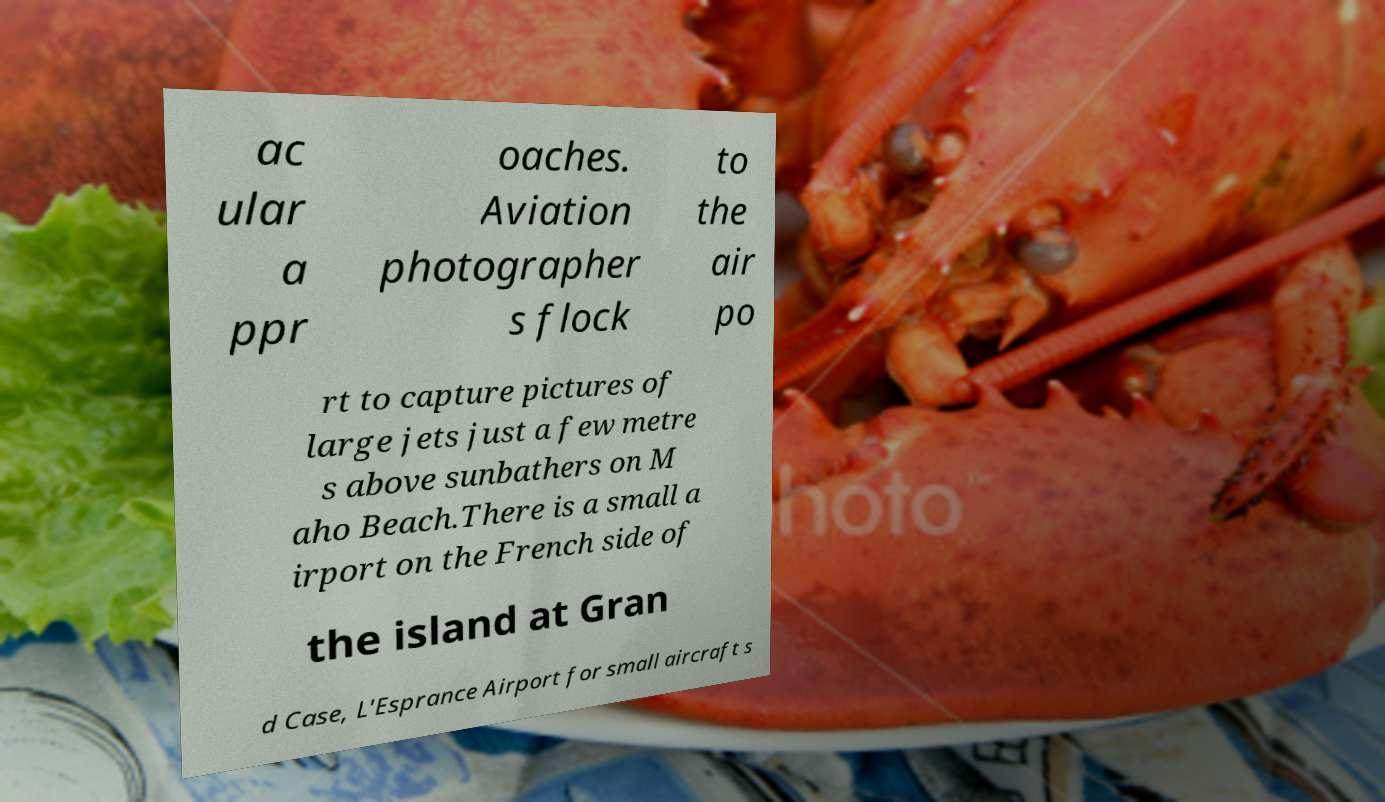Can you accurately transcribe the text from the provided image for me? ac ular a ppr oaches. Aviation photographer s flock to the air po rt to capture pictures of large jets just a few metre s above sunbathers on M aho Beach.There is a small a irport on the French side of the island at Gran d Case, L'Esprance Airport for small aircraft s 